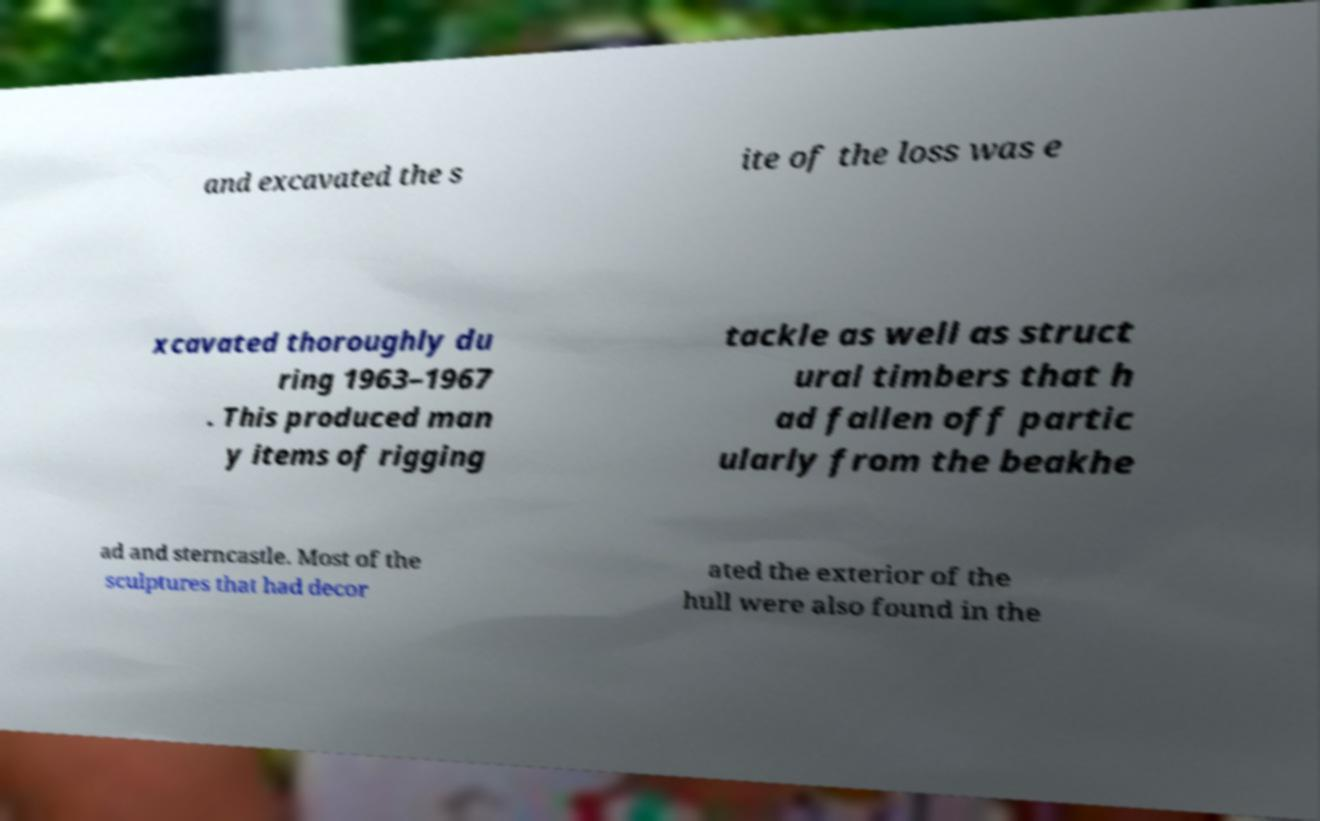Could you assist in decoding the text presented in this image and type it out clearly? and excavated the s ite of the loss was e xcavated thoroughly du ring 1963–1967 . This produced man y items of rigging tackle as well as struct ural timbers that h ad fallen off partic ularly from the beakhe ad and sterncastle. Most of the sculptures that had decor ated the exterior of the hull were also found in the 